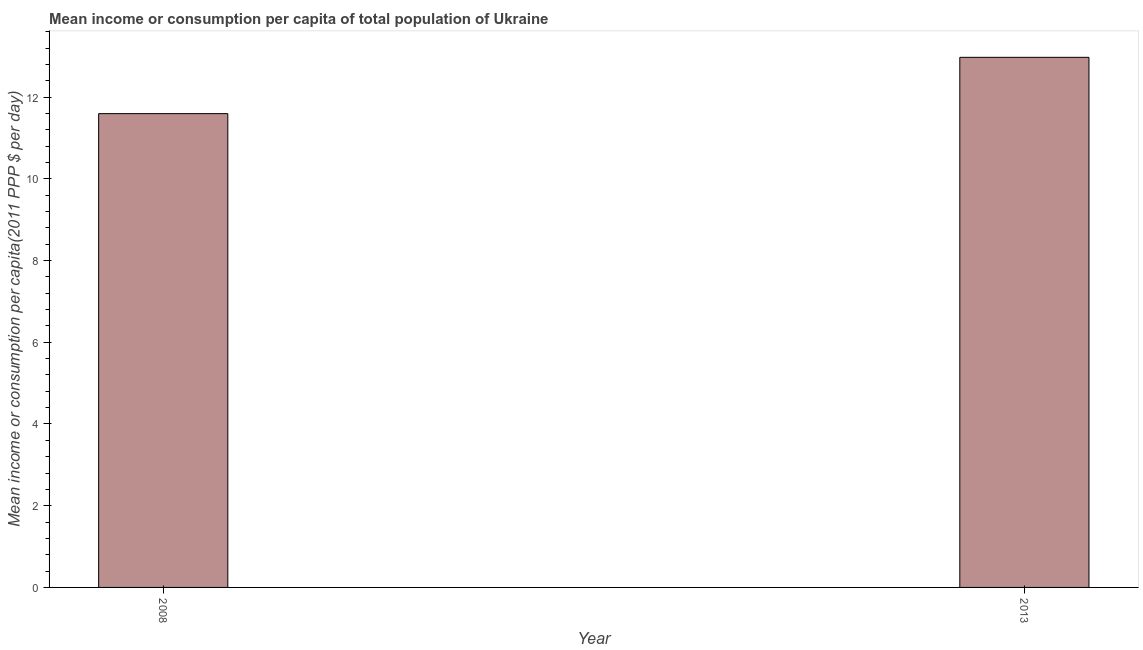Does the graph contain any zero values?
Provide a short and direct response. No. What is the title of the graph?
Provide a succinct answer. Mean income or consumption per capita of total population of Ukraine. What is the label or title of the X-axis?
Your answer should be very brief. Year. What is the label or title of the Y-axis?
Your answer should be very brief. Mean income or consumption per capita(2011 PPP $ per day). What is the mean income or consumption in 2008?
Provide a short and direct response. 11.6. Across all years, what is the maximum mean income or consumption?
Keep it short and to the point. 12.97. Across all years, what is the minimum mean income or consumption?
Provide a succinct answer. 11.6. What is the sum of the mean income or consumption?
Offer a terse response. 24.57. What is the difference between the mean income or consumption in 2008 and 2013?
Offer a terse response. -1.38. What is the average mean income or consumption per year?
Ensure brevity in your answer.  12.29. What is the median mean income or consumption?
Make the answer very short. 12.29. Do a majority of the years between 2008 and 2013 (inclusive) have mean income or consumption greater than 0.4 $?
Your answer should be compact. Yes. What is the ratio of the mean income or consumption in 2008 to that in 2013?
Your response must be concise. 0.89. Are the values on the major ticks of Y-axis written in scientific E-notation?
Offer a very short reply. No. What is the Mean income or consumption per capita(2011 PPP $ per day) in 2008?
Offer a very short reply. 11.6. What is the Mean income or consumption per capita(2011 PPP $ per day) of 2013?
Your answer should be very brief. 12.97. What is the difference between the Mean income or consumption per capita(2011 PPP $ per day) in 2008 and 2013?
Provide a short and direct response. -1.38. What is the ratio of the Mean income or consumption per capita(2011 PPP $ per day) in 2008 to that in 2013?
Make the answer very short. 0.89. 